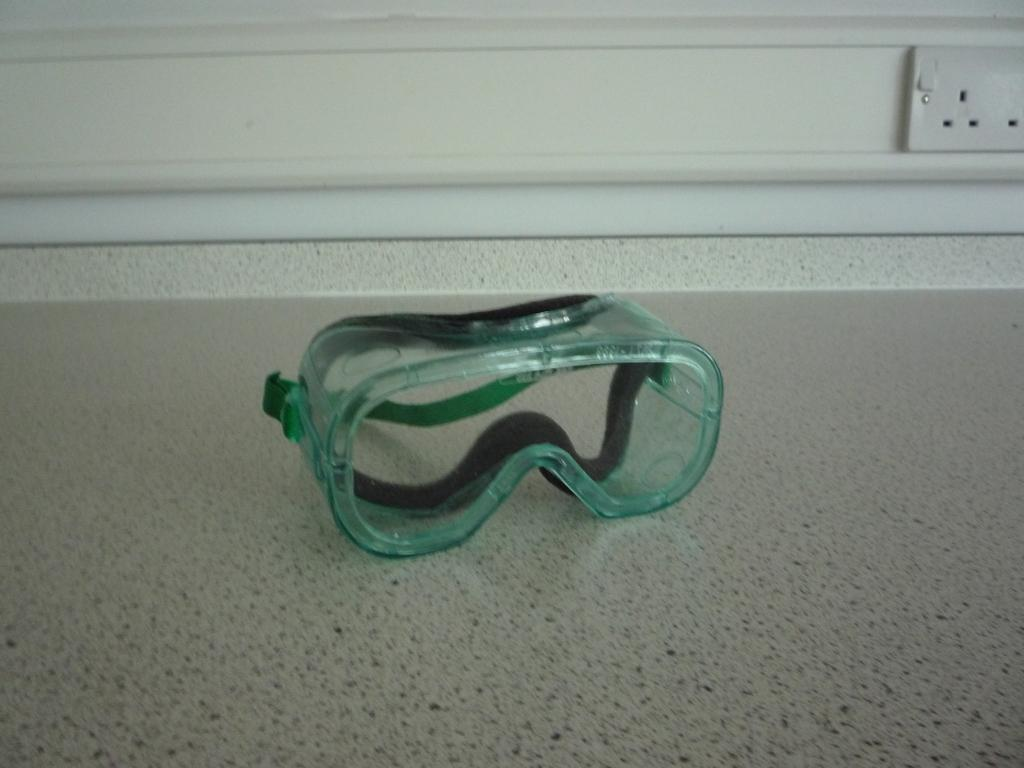What is the main object in the center of the image? There are goggles in the center of the image. Where are the goggles located? The goggles are placed on the floor. What can be seen in the background of the image? There is a wall in the background of the image. Is there any electrical outlet visible on the wall? Yes, there is a plug socket placed on the wall. What type of polish is being applied to the goggles in the image? There is no polish being applied to the goggles in the image; they are simply placed on the floor. 